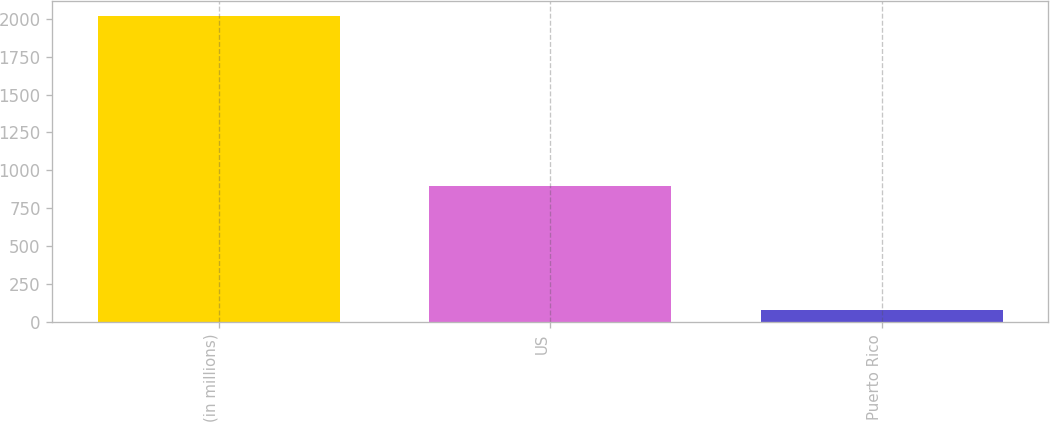Convert chart. <chart><loc_0><loc_0><loc_500><loc_500><bar_chart><fcel>(in millions)<fcel>US<fcel>Puerto Rico<nl><fcel>2015<fcel>898<fcel>80<nl></chart> 